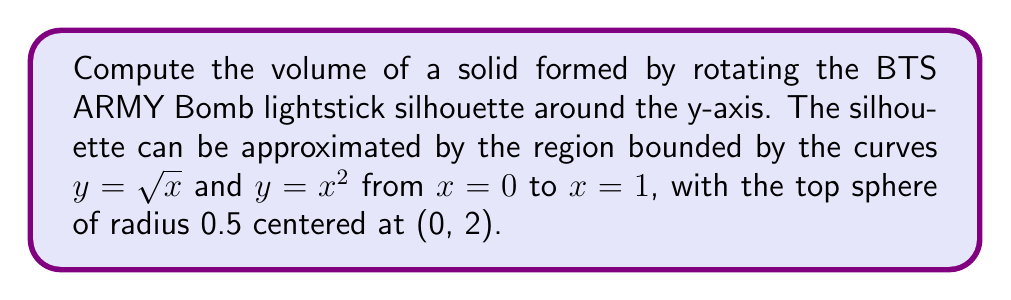Solve this math problem. Let's approach this problem step-by-step:

1) The volume of a solid of revolution around the y-axis is given by the formula:

   $$V = \pi \int_a^b [f(y)^2 - g(y)^2] dy$$

   where $f(y)$ is the outer function and $g(y)$ is the inner function.

2) We need to express our curves in terms of y:
   $y = \sqrt{x}$ becomes $x = y^2$
   $y = x^2$ becomes $x = \sqrt{y}$

3) The limits of integration will be from $y = 0$ to $y = 1$

4) Our integral becomes:

   $$V_1 = \pi \int_0^1 [(y^2)^2 - (\sqrt{y})^2] dy = \pi \int_0^1 [y^4 - y] dy$$

5) Solving this integral:

   $$V_1 = \pi [\frac{y^5}{5} - \frac{y^2}{2}]_0^1 = \pi (\frac{1}{5} - \frac{1}{2}) = \pi (\frac{2-5}{10}) = -\frac{3\pi}{10}$$

6) For the top sphere, we use the formula for the volume of a sphere:

   $$V_2 = \frac{4}{3}\pi r^3 = \frac{4}{3}\pi (0.5)^3 = \frac{\pi}{6}$$

7) The total volume is the sum of these two parts:

   $$V_{total} = V_1 + V_2 = -\frac{3\pi}{10} + \frac{\pi}{6} = \frac{-9\pi + 5\pi}{30} = -\frac{4\pi}{30} = -\frac{2\pi}{15}$$
Answer: $-\frac{2\pi}{15}$ cubic units 